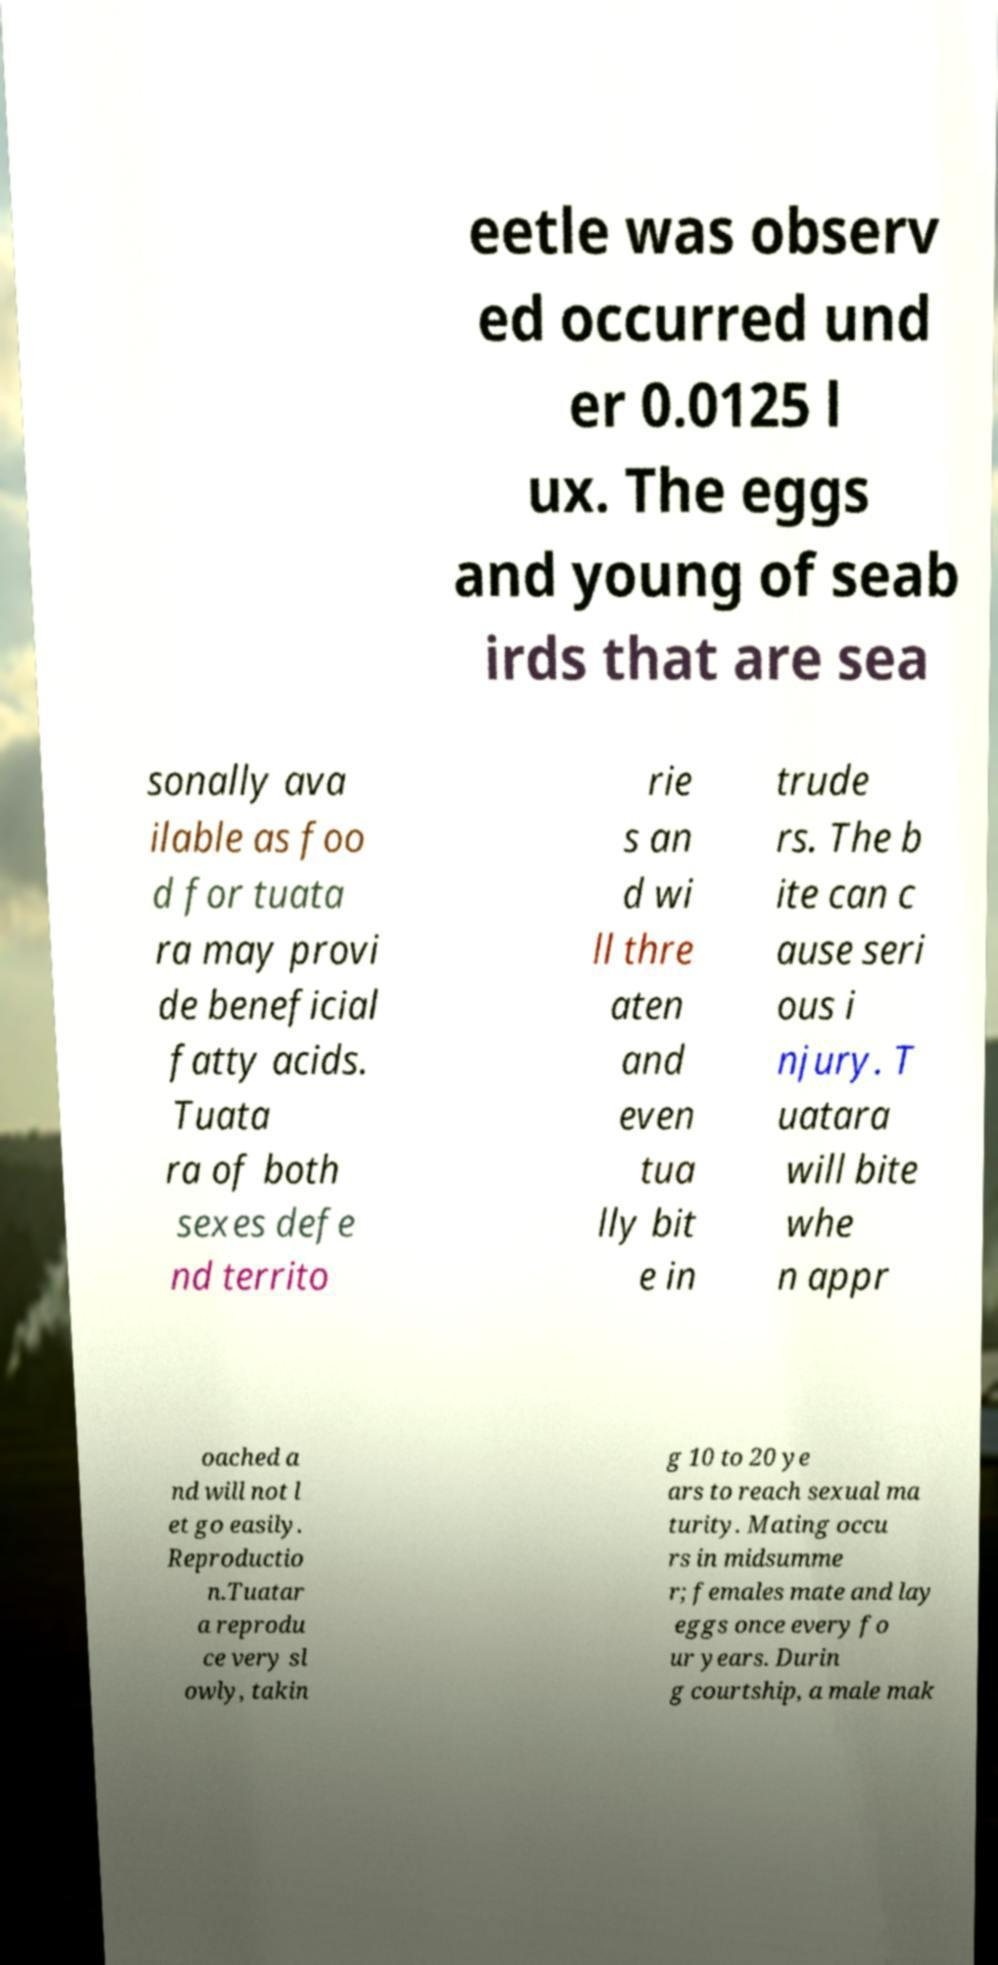Could you assist in decoding the text presented in this image and type it out clearly? eetle was observ ed occurred und er 0.0125 l ux. The eggs and young of seab irds that are sea sonally ava ilable as foo d for tuata ra may provi de beneficial fatty acids. Tuata ra of both sexes defe nd territo rie s an d wi ll thre aten and even tua lly bit e in trude rs. The b ite can c ause seri ous i njury. T uatara will bite whe n appr oached a nd will not l et go easily. Reproductio n.Tuatar a reprodu ce very sl owly, takin g 10 to 20 ye ars to reach sexual ma turity. Mating occu rs in midsumme r; females mate and lay eggs once every fo ur years. Durin g courtship, a male mak 